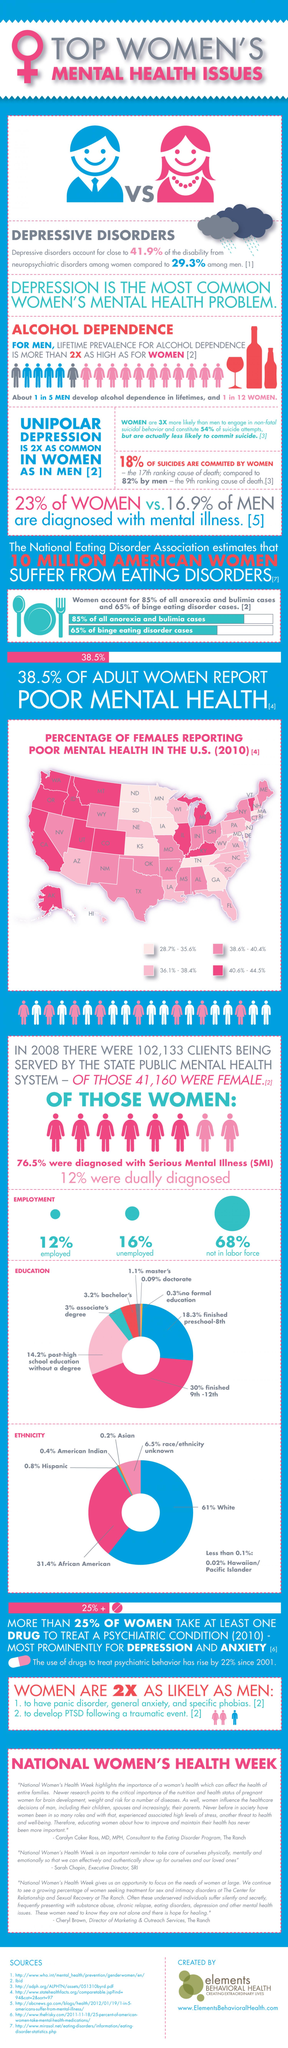Identify some key points in this picture. According to recent data, approximately 68% of women are not currently participating in the labor force. This represents a significant portion of the female population and highlights the need for policies and initiatives aimed at increasing female labor force participation. According to reported data, in the United States, a range of 40.6% to 44.5% of females have poor mental health. Overall, 13 states reported these numbers. According to recent statistics, only 12% of women are employed. According to a recent study, it was found that 77% of women are not diagnosed with mental illness. According to a recent study, approximately 35% of women have not suffered from binge eating disorder cases. 